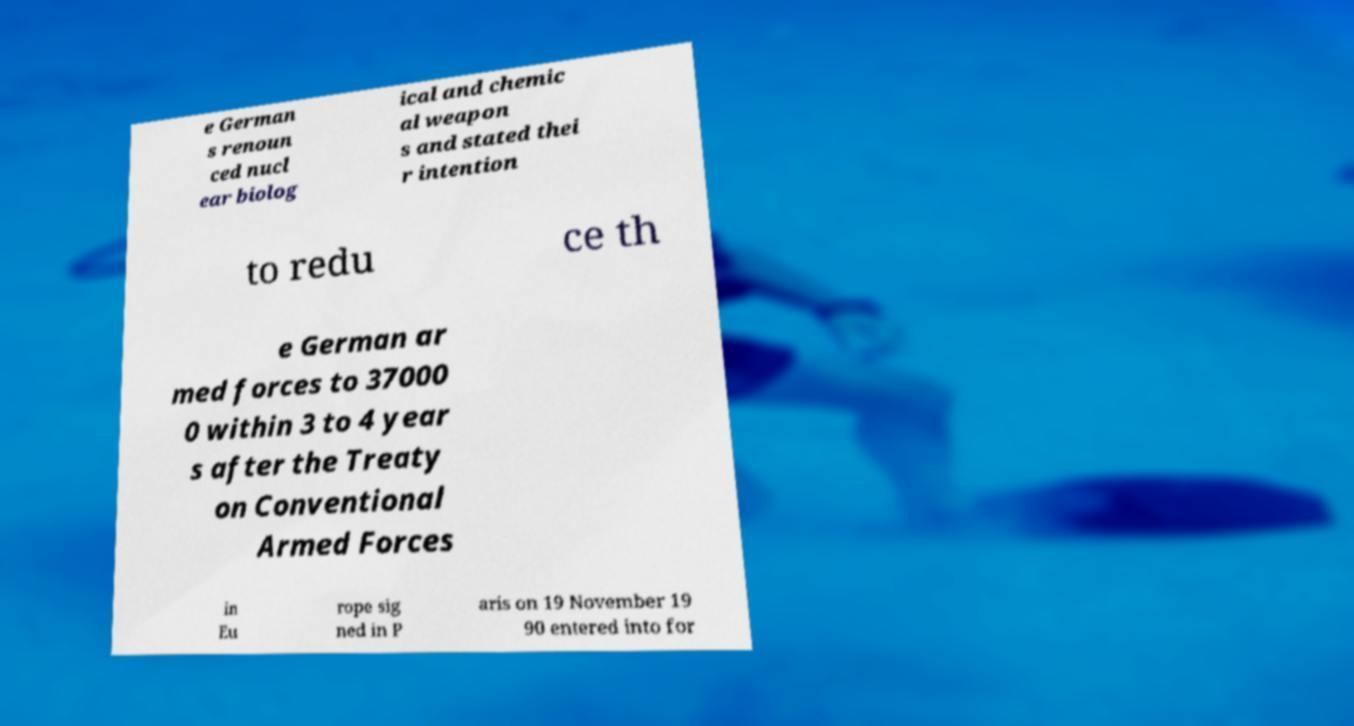Could you extract and type out the text from this image? e German s renoun ced nucl ear biolog ical and chemic al weapon s and stated thei r intention to redu ce th e German ar med forces to 37000 0 within 3 to 4 year s after the Treaty on Conventional Armed Forces in Eu rope sig ned in P aris on 19 November 19 90 entered into for 